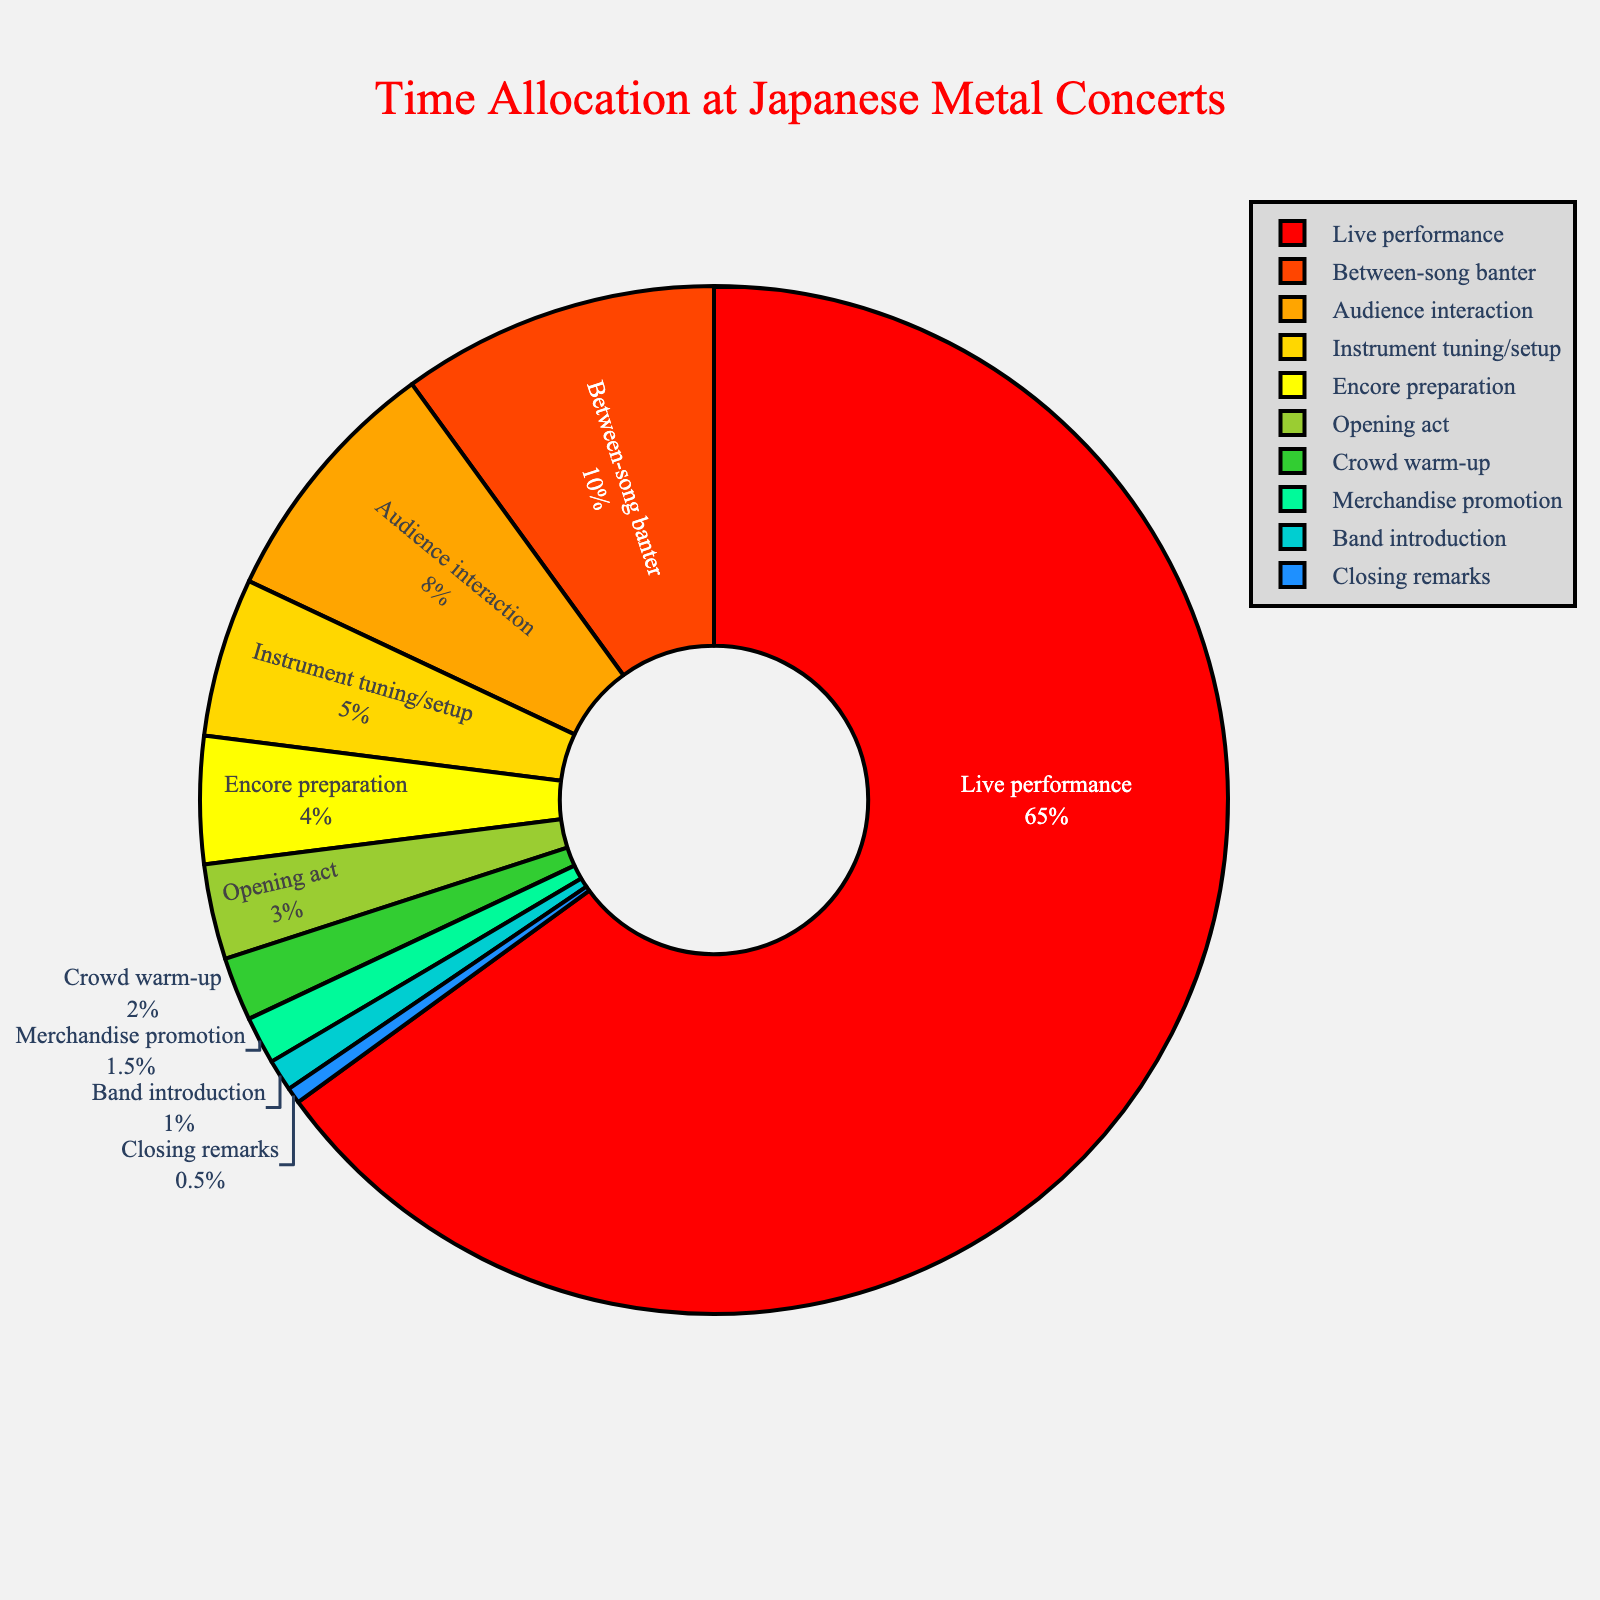What's the largest percentage activity during the concert? The chart shows various activities with their corresponding percentages. By examining each segment, the largest one is for 'Live performance' which is 65%.
Answer: Live performance What is the combined percentage of "Instrument tuning/setup" and "Encore preparation"? "Instrument tuning/setup" has 5% and "Encore preparation" has 4%. Adding them together gives 5% + 4% = 9%.
Answer: 9% Which activity has a greater percentage, "Between-song banter" or "Audience interaction"? The chart shows "Between-song banter" at 10% and "Audience interaction" at 8%. Since 10% > 8%, "Between-song banter" has a greater percentage than "Audience interaction".
Answer: Between-song banter How much more percentage does the "Live performance" take compared to the "Opening act"? The chart shows that "Live performance" is 65% and "Opening act" is 3%. The difference is 65% - 3% = 62%.
Answer: 62% What is the total percentage of time spent on activities other than "Live performance"? "Live performance" is 65%, so the remaining percentage is 100% - 65% = 35%.
Answer: 35% Which activities combined form at least a 15% share of the concert? The activities and their percentages are: "Between-song banter" (10%), "Audience interaction" (8%), "Instrument tuning/setup" (5%), "Encore preparation" (4%), "Opening act" (3%), "Crowd warm-up" (2%), "Merchandise promotion" (1.5%), "Band introduction" (1%), and "Closing remarks" (0.5%). Combining "Between-song banter" with any of the other activities doesn't reach 15%, but "Between-song banter" and "Audience interaction" together give 10% + 8% = 18%.
Answer: Between-song banter and Audience interaction What are the visual markers used to differentiate between activities? The chart uses different colors for each activity segment and a black line bordering each segment to differentiate visually.
Answer: Colors and borders Which activities take the least amount of time during the concert? The activities with the smallest segments are "Band introduction" (1%) and "Closing remarks" (0.5%).
Answer: Band introduction and Closing remarks Which activities' combined percentage is less than half of the "Audience interaction" time? "Audience interaction" is 8%. Activities with percentages less than half of this are "Merchandise promotion" (1.5%), "Band introduction" (1%), and "Closing remarks" (0.5%). Their combined percentage is 1.5% + 1% + 0.5% = 3%.
Answer: Merchandise promotion, Band introduction, and Closing remarks 